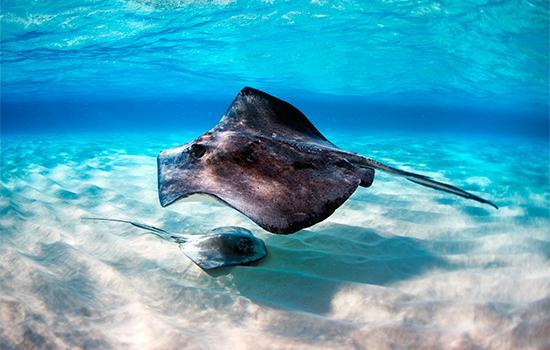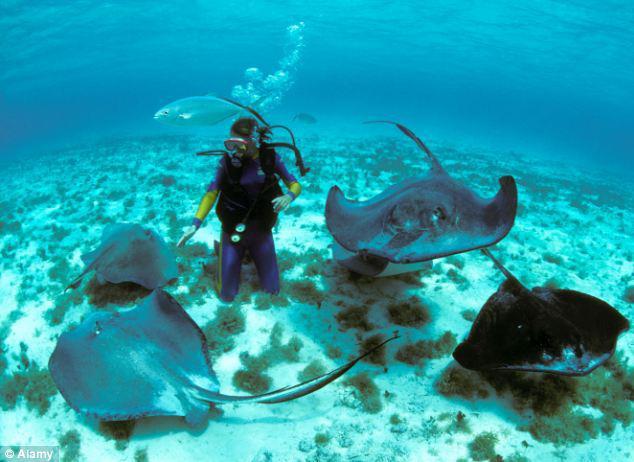The first image is the image on the left, the second image is the image on the right. Given the left and right images, does the statement "There are at most three stingrays." hold true? Answer yes or no. No. 